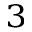Convert formula to latex. <formula><loc_0><loc_0><loc_500><loc_500>_ { 3 }</formula> 